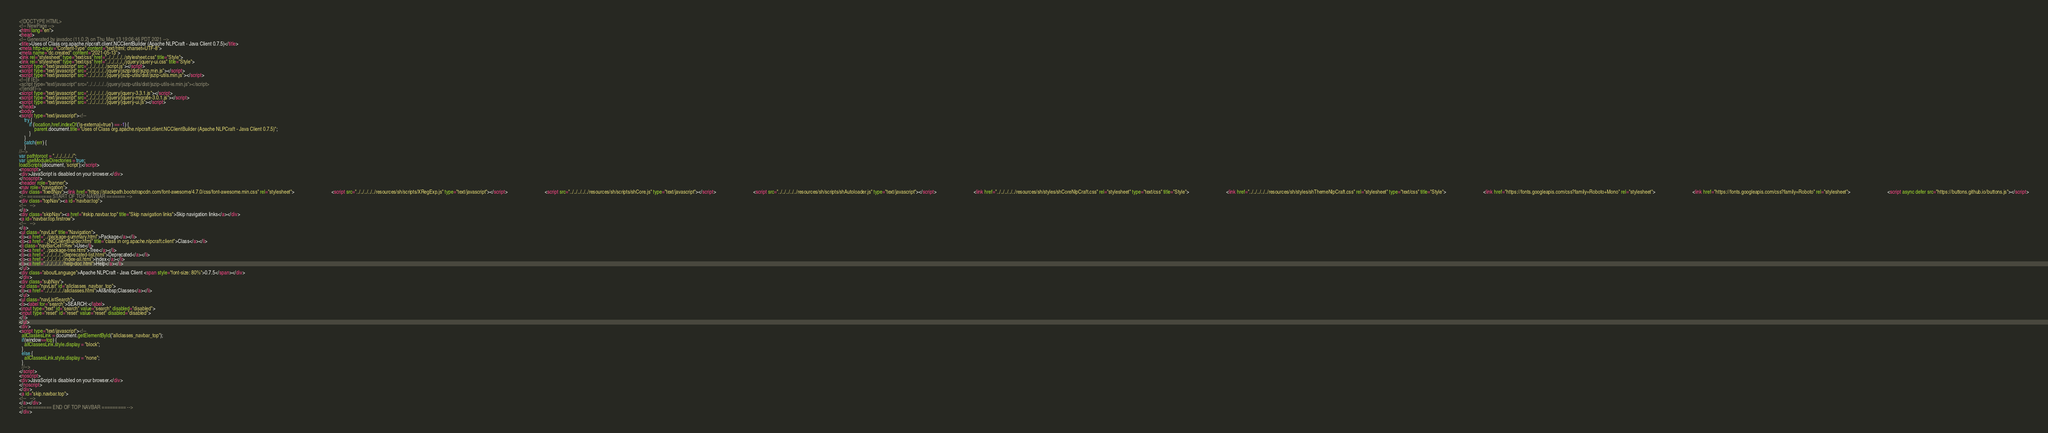Convert code to text. <code><loc_0><loc_0><loc_500><loc_500><_HTML_><!DOCTYPE HTML>
<!-- NewPage -->
<html lang="en">
<head>
<!-- Generated by javadoc (11.0.2) on Thu May 13 19:06:46 PDT 2021 -->
<title>Uses of Class org.apache.nlpcraft.client.NCClientBuilder (Apache NLPCraft - Java Client 0.7.5)</title>
<meta http-equiv="Content-Type" content="text/html; charset=UTF-8">
<meta name="dc.created" content="2021-05-13">
<link rel="stylesheet" type="text/css" href="../../../../../stylesheet.css" title="Style">
<link rel="stylesheet" type="text/css" href="../../../../../jquery/jquery-ui.css" title="Style">
<script type="text/javascript" src="../../../../../script.js"></script>
<script type="text/javascript" src="../../../../../jquery/jszip/dist/jszip.min.js"></script>
<script type="text/javascript" src="../../../../../jquery/jszip-utils/dist/jszip-utils.min.js"></script>
<!--[if IE]>
<script type="text/javascript" src="../../../../../jquery/jszip-utils/dist/jszip-utils-ie.min.js"></script>
<![endif]-->
<script type="text/javascript" src="../../../../../jquery/jquery-3.3.1.js"></script>
<script type="text/javascript" src="../../../../../jquery/jquery-migrate-3.0.1.js"></script>
<script type="text/javascript" src="../../../../../jquery/jquery-ui.js"></script>
</head>
<body>
<script type="text/javascript"><!--
    try {
        if (location.href.indexOf('is-external=true') == -1) {
            parent.document.title="Uses of Class org.apache.nlpcraft.client.NCClientBuilder (Apache NLPCraft - Java Client 0.7.5)";
        }
    }
    catch(err) {
    }
//-->
var pathtoroot = "../../../../../";
var useModuleDirectories = true;
loadScripts(document, 'script');</script>
<noscript>
<div>JavaScript is disabled on your browser.</div>
</noscript>
<header role="banner">
<nav role="navigation">
<div class="fixedNav"><link href="https://stackpath.bootstrapcdn.com/font-awesome/4.7.0/css/font-awesome.min.css" rel="stylesheet">                             <script src="../../../../../resources/sh/scripts/XRegExp.js" type="text/javascript"></script>                             <script src="../../../../../resources/sh/scripts/shCore.js" type="text/javascript"></script>                             <script src="../../../../../resources/sh/scripts/shAutoloader.js" type="text/javascript"></script>                             <link href="../../../../../resources/sh/styles/shCoreNlpCraft.css" rel="stylesheet" type="text/css" title="Style">                             <link href="../../../../../resources/sh/styles/shThemeNlpCraft.css" rel="stylesheet" type="text/css" title="Style">                             <link href="https://fonts.googleapis.com/css?family=Roboto+Mono" rel="stylesheet">                             <link href="https://fonts.googleapis.com/css?family=Roboto" rel="stylesheet">                             <script async defer src="https://buttons.github.io/buttons.js"></script>
<!-- ========= START OF TOP NAVBAR ======= -->
<div class="topNav"><a id="navbar.top">
<!--   -->
</a>
<div class="skipNav"><a href="#skip.navbar.top" title="Skip navigation links">Skip navigation links</a></div>
<a id="navbar.top.firstrow">
<!--   -->
</a>
<ul class="navList" title="Navigation">
<li><a href="../package-summary.html">Package</a></li>
<li><a href="../NCClientBuilder.html" title="class in org.apache.nlpcraft.client">Class</a></li>
<li class="navBarCell1Rev">Use</li>
<li><a href="../package-tree.html">Tree</a></li>
<li><a href="../../../../../deprecated-list.html">Deprecated</a></li>
<li><a href="../../../../../index-all.html">Index</a></li>
<li><a href="../../../../../help-doc.html">Help</a></li>
</ul>
<div class="aboutLanguage">Apache NLPCraft - Java Client <span style="font-size: 80%">0.7.5</span></div>
</div>
<div class="subNav">
<ul class="navList" id="allclasses_navbar_top">
<li><a href="../../../../../allclasses.html">All&nbsp;Classes</a></li>
</ul>
<ul class="navListSearch">
<li><label for="search">SEARCH:</label>
<input type="text" id="search" value="search" disabled="disabled">
<input type="reset" id="reset" value="reset" disabled="disabled">
</li>
</ul>
<div>
<script type="text/javascript"><!--
  allClassesLink = document.getElementById("allclasses_navbar_top");
  if(window==top) {
    allClassesLink.style.display = "block";
  }
  else {
    allClassesLink.style.display = "none";
  }
  //-->
</script>
<noscript>
<div>JavaScript is disabled on your browser.</div>
</noscript>
</div>
<a id="skip.navbar.top">
<!--   -->
</a></div>
<!-- ========= END OF TOP NAVBAR ========= -->
</div></code> 